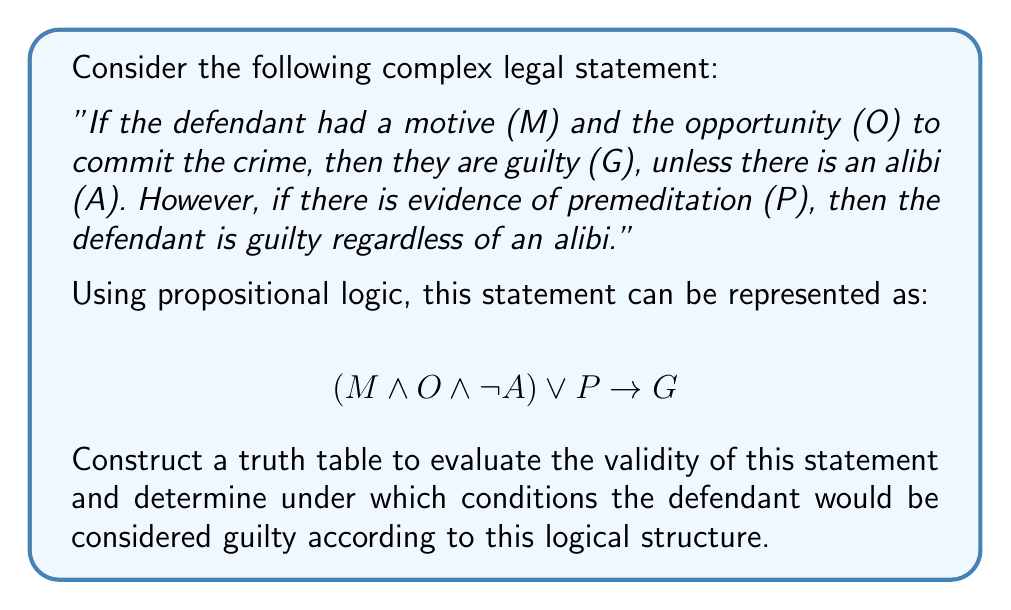Help me with this question. To evaluate this complex legal statement using a truth table, we need to consider all possible combinations of the propositional variables: M (motive), O (opportunity), A (alibi), P (premeditation), and G (guilt). We'll construct a truth table with 32 rows ($2^5$ combinations) to cover all possibilities.

Step 1: Set up the truth table columns
We'll create columns for each variable (M, O, A, P, G) and for each sub-expression in the logical statement.

Step 2: Fill in the truth values for each variable
Fill in all possible combinations of T (true) and F (false) for M, O, A, and P.

Step 3: Evaluate sub-expressions
a) $M \land O$
b) $(M \land O) \land \neg A$
c) $(M \land O \land \neg A) \lor P$

Step 4: Evaluate the full expression
$$(M \land O \land \neg A) \lor P \rightarrow G$$

The truth table will look like this (showing only a few rows for brevity):

| M | O | A | P | $M \land O$ | $(M \land O) \land \neg A$ | $(M \land O \land \neg A) \lor P$ | G | Result |
|---|---|---|---|-------------|----------------------------|----------------------------------|---|--------|
| T | T | T | T | T           | F                          | T                                | T | T      |
| T | T | T | F | T           | F                          | F                                | T | T      |
| T | T | F | T | T           | T                          | T                                | T | T      |
| T | T | F | F | T           | T                          | T                                | F | F      |
...

Step 5: Analyze the results
The statement is valid (i.e., the implication is true) in all cases except when:
a) $(M \land O \land \neg A) \lor P$ is true, but G is false
b) P is true, but G is false

The conditions for guilt (G being true) according to this logical structure are:
1. When there is evidence of premeditation (P is true), regardless of other factors.
2. When there is motive (M) and opportunity (O), and no alibi (A is false), even if there's no premeditation.

This truth table analysis helps evaluate the logical consistency of the legal statement and identifies the specific conditions under which guilt would be determined according to this logical framework.
Answer: The complex legal statement is valid in most cases, but not all. The defendant would be considered guilty under the following conditions:
1. When there is evidence of premeditation (P is true).
2. When there is motive (M) and opportunity (O), and no alibi (A is false).

The statement is invalid (i.e., the implication is false) when:
a) $(M \land O \land \neg A) \lor P$ is true, but G is false
b) P is true, but G is false

This logical analysis reveals potential inconsistencies in the legal reasoning that a criminal law expert might need to address when constructing or evaluating arguments in a case. 